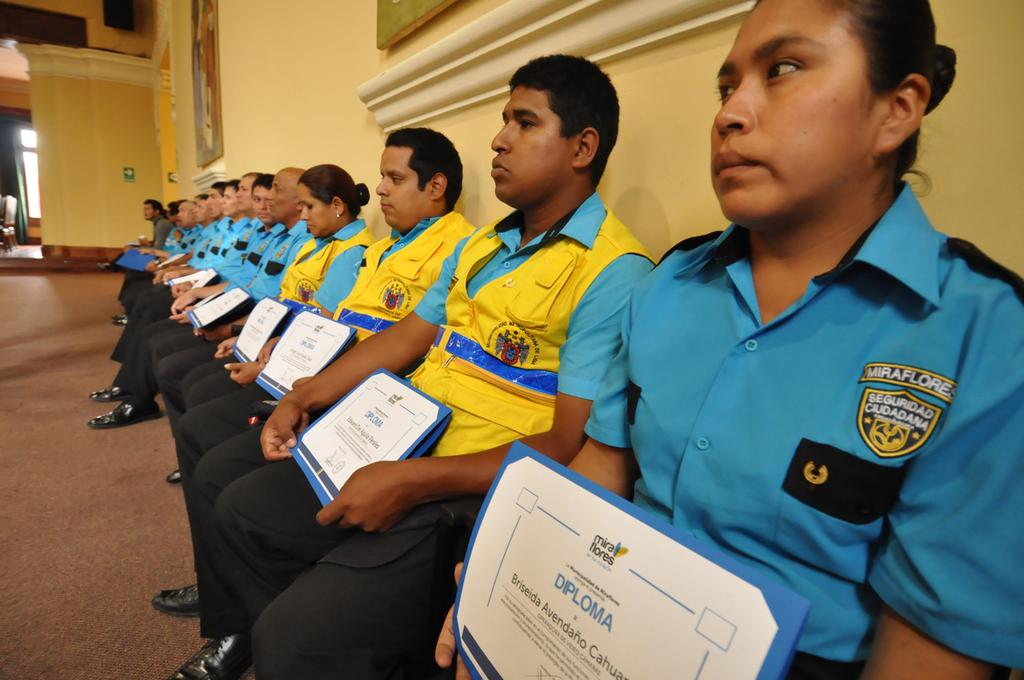What are the people in the image doing? The people in the image are sitting. What are the people holding in the image? The people are holding certificates. What can be seen in the background of the image? There is a wall in the background of the image. What type of footwear are the people wearing? The people are wearing shoes. What type of tomatoes can be seen on the person's head in the image? There are no tomatoes present in the image, and no person has tomatoes on their head. 